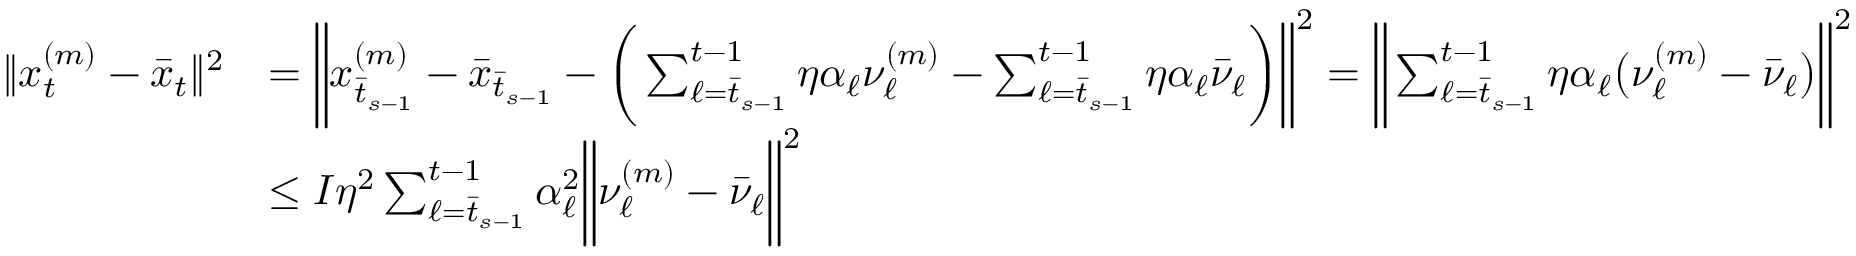Convert formula to latex. <formula><loc_0><loc_0><loc_500><loc_500>\begin{array} { r l } { \| x _ { t } ^ { ( m ) } - \bar { x } _ { t } \| ^ { 2 } } & { = \left \| x _ { \bar { t } _ { s - 1 } } ^ { ( m ) } - \bar { x } _ { \bar { t } _ { s - 1 } } - \left ( \sum _ { \ell = \bar { t } _ { s - 1 } } ^ { t - 1 } \eta \alpha _ { \ell } \nu _ { \ell } ^ { ( m ) } - \sum _ { \ell = \bar { t } _ { s - 1 } } ^ { t - 1 } \eta \alpha _ { \ell } \bar { \nu } _ { \ell } \right ) \right \| ^ { 2 } = \left \| \sum _ { \ell = \bar { t } _ { s - 1 } } ^ { t - 1 } \eta \alpha _ { \ell } \left ( \nu _ { \ell } ^ { ( m ) } - \bar { \nu } _ { \ell } \right ) \right \| ^ { 2 } } \\ & { \leq I \eta ^ { 2 } \sum _ { \ell = \bar { t } _ { s - 1 } } ^ { t - 1 } \alpha _ { \ell } ^ { 2 } \left \| \nu _ { \ell } ^ { ( m ) } - \bar { \nu } _ { \ell } \right \| ^ { 2 } } \end{array}</formula> 